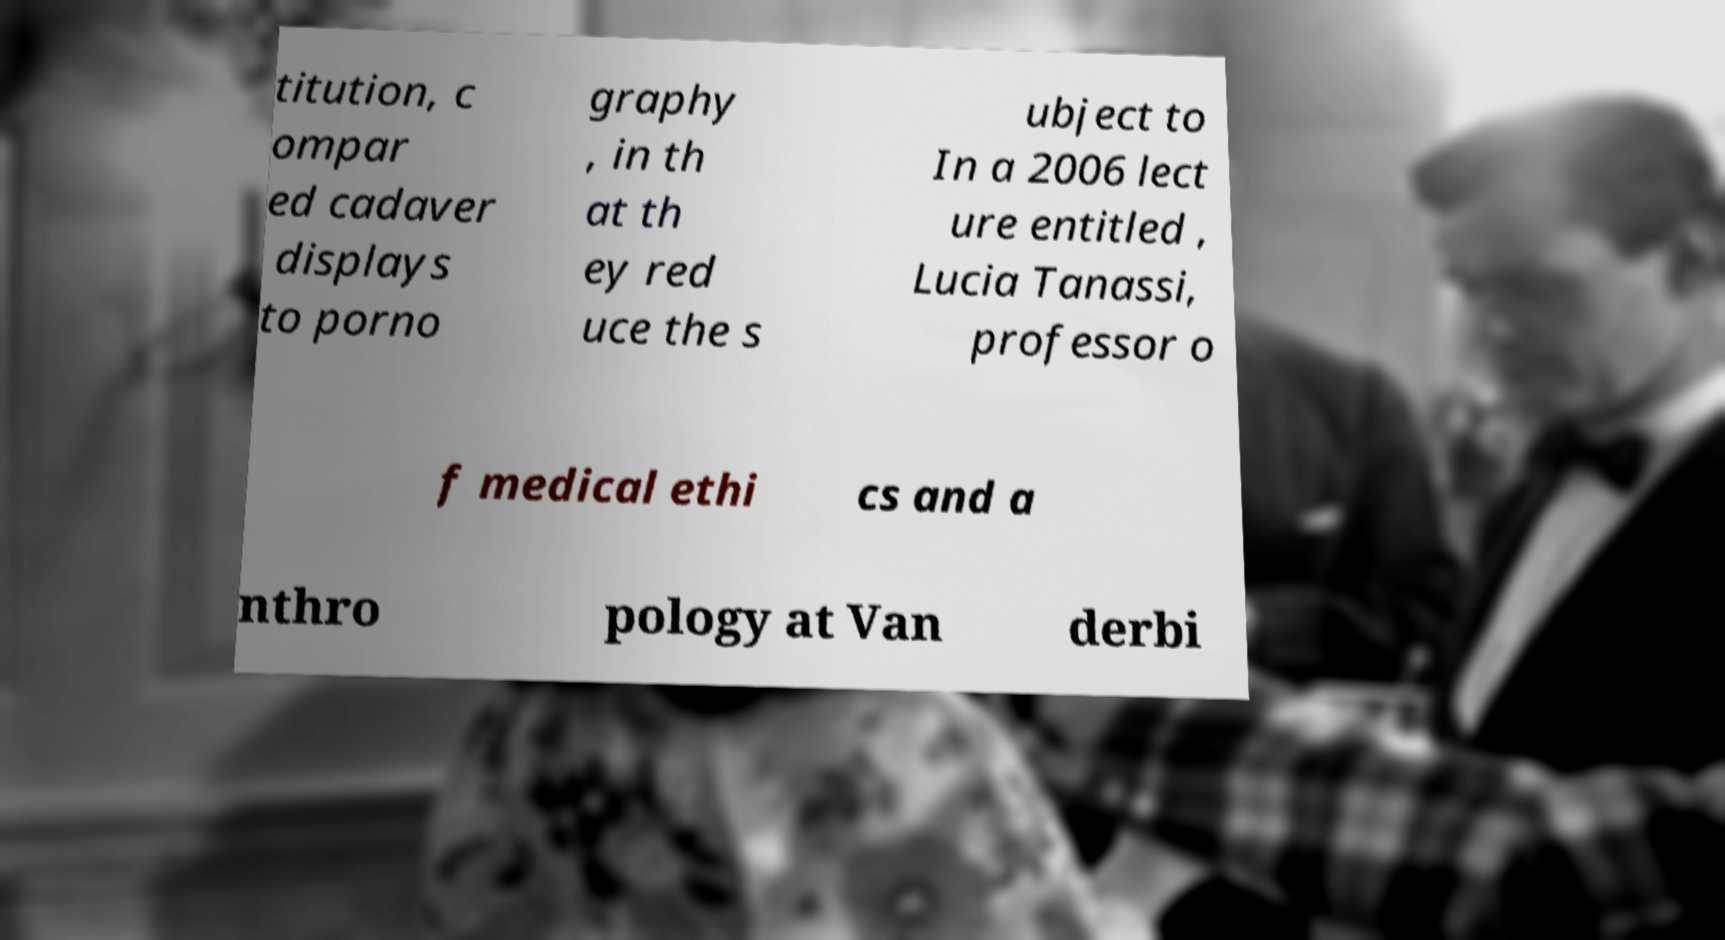There's text embedded in this image that I need extracted. Can you transcribe it verbatim? titution, c ompar ed cadaver displays to porno graphy , in th at th ey red uce the s ubject to In a 2006 lect ure entitled , Lucia Tanassi, professor o f medical ethi cs and a nthro pology at Van derbi 